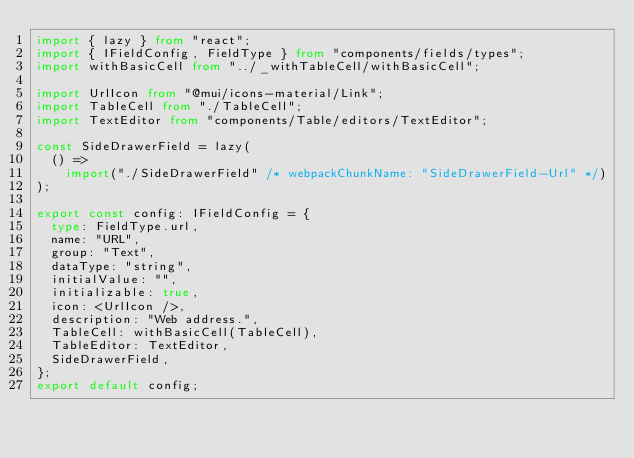<code> <loc_0><loc_0><loc_500><loc_500><_TypeScript_>import { lazy } from "react";
import { IFieldConfig, FieldType } from "components/fields/types";
import withBasicCell from "../_withTableCell/withBasicCell";

import UrlIcon from "@mui/icons-material/Link";
import TableCell from "./TableCell";
import TextEditor from "components/Table/editors/TextEditor";

const SideDrawerField = lazy(
  () =>
    import("./SideDrawerField" /* webpackChunkName: "SideDrawerField-Url" */)
);

export const config: IFieldConfig = {
  type: FieldType.url,
  name: "URL",
  group: "Text",
  dataType: "string",
  initialValue: "",
  initializable: true,
  icon: <UrlIcon />,
  description: "Web address.",
  TableCell: withBasicCell(TableCell),
  TableEditor: TextEditor,
  SideDrawerField,
};
export default config;
</code> 